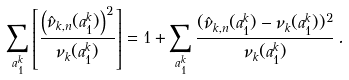<formula> <loc_0><loc_0><loc_500><loc_500>\sum _ { a _ { 1 } ^ { k } } \left [ \frac { \left ( \hat { \nu } _ { k , n } ( a _ { 1 } ^ { k } ) \right ) ^ { 2 } } { \nu _ { k } ( a _ { 1 } ^ { k } ) } \right ] = 1 + \sum _ { a ^ { k } _ { 1 } } \frac { ( \hat { \nu } _ { k , n } ( a ^ { k } _ { 1 } ) - \nu _ { k } ( a ^ { k } _ { 1 } ) ) ^ { 2 } } { \nu _ { k } ( a ^ { k } _ { 1 } ) } \, .</formula> 